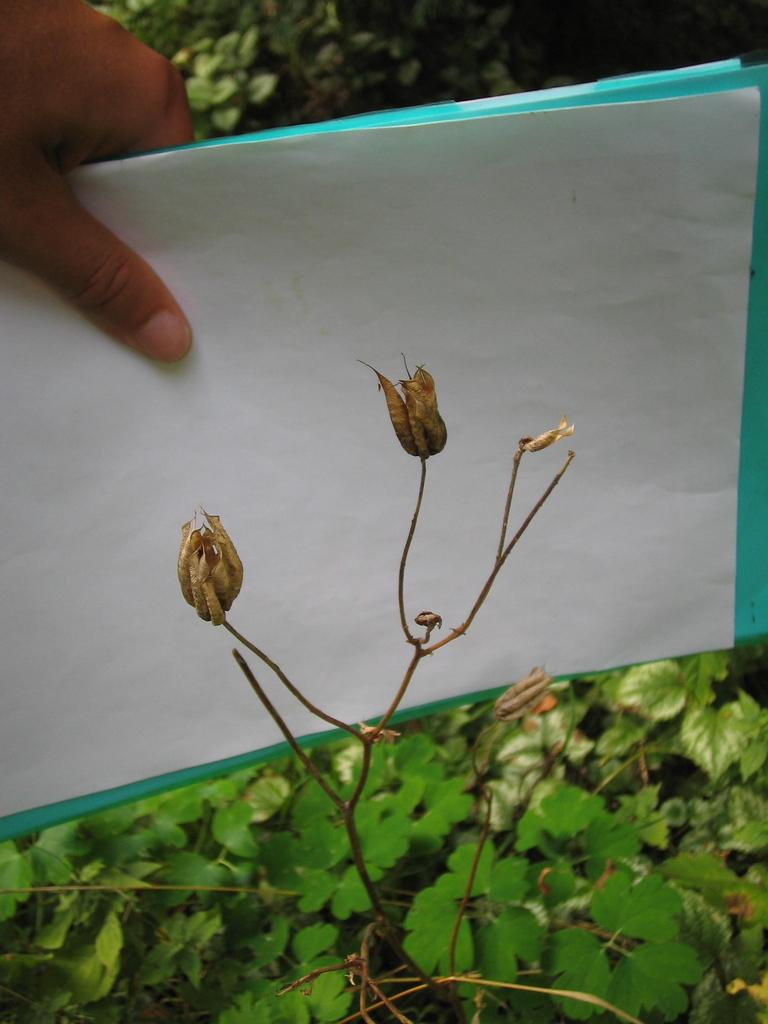What is the main subject of the image? There is a person in the image. What is the person holding in their hand? The person is holding papers in their hand. What type of vegetation can be seen in the image? There are creepers and plants in the image. Can you describe the lighting in the image? The image was likely taken during the day, as there is sufficient light. How many lizards can be seen sitting on the seat in the image? There are no lizards or seats present in the image. Is there a boat visible in the image? There is no boat visible in the image. 